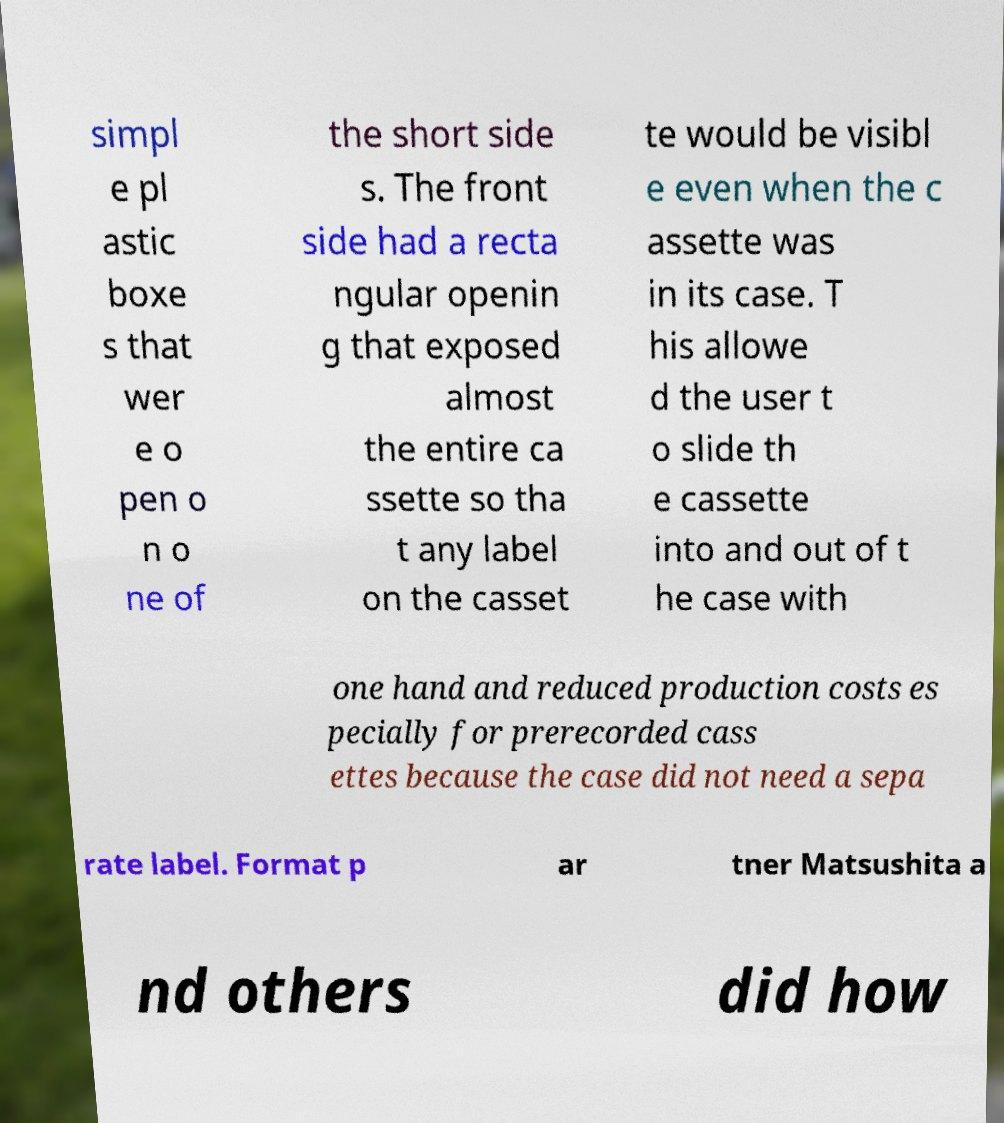There's text embedded in this image that I need extracted. Can you transcribe it verbatim? simpl e pl astic boxe s that wer e o pen o n o ne of the short side s. The front side had a recta ngular openin g that exposed almost the entire ca ssette so tha t any label on the casset te would be visibl e even when the c assette was in its case. T his allowe d the user t o slide th e cassette into and out of t he case with one hand and reduced production costs es pecially for prerecorded cass ettes because the case did not need a sepa rate label. Format p ar tner Matsushita a nd others did how 